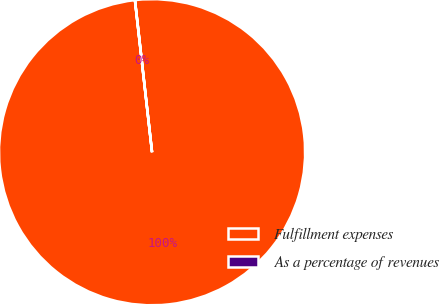<chart> <loc_0><loc_0><loc_500><loc_500><pie_chart><fcel>Fulfillment expenses<fcel>As a percentage of revenues<nl><fcel>99.99%<fcel>0.01%<nl></chart> 